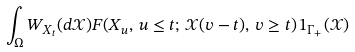Convert formula to latex. <formula><loc_0><loc_0><loc_500><loc_500>\int _ { \Omega } { W } _ { X _ { t } } ( d \mathcal { X } ) F ( X _ { u } , \, u \leq t ; \, \mathcal { X } ( v - t ) , \, v \geq t ) \, 1 _ { \Gamma _ { + } } ( \mathcal { X } )</formula> 